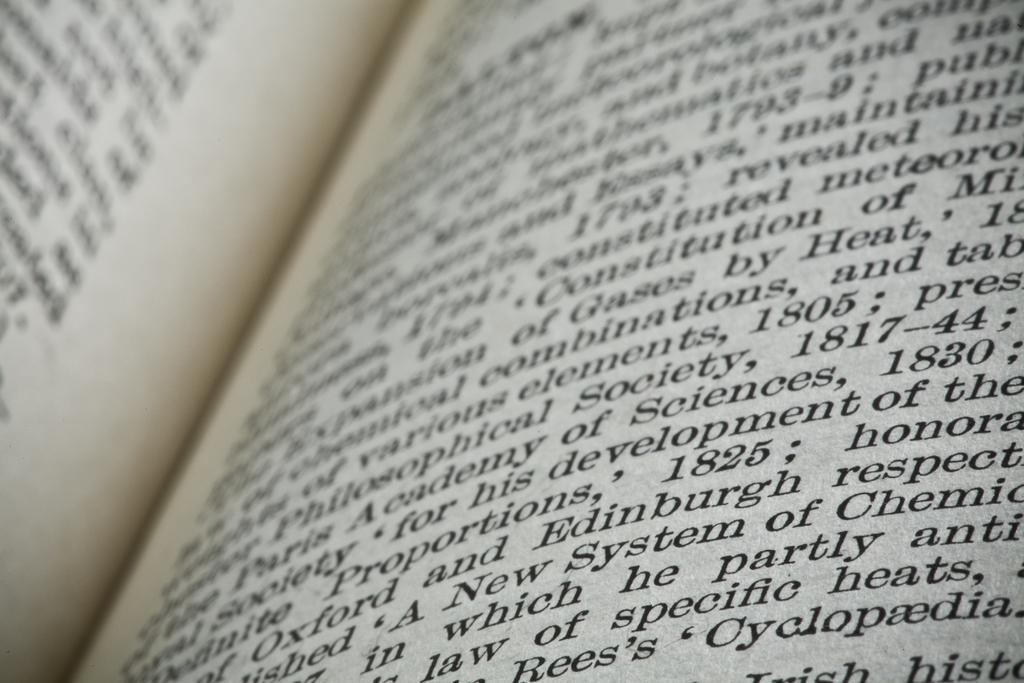<image>
Render a clear and concise summary of the photo. A book with the word Cyclopaedia near the bottom right corner is open. 